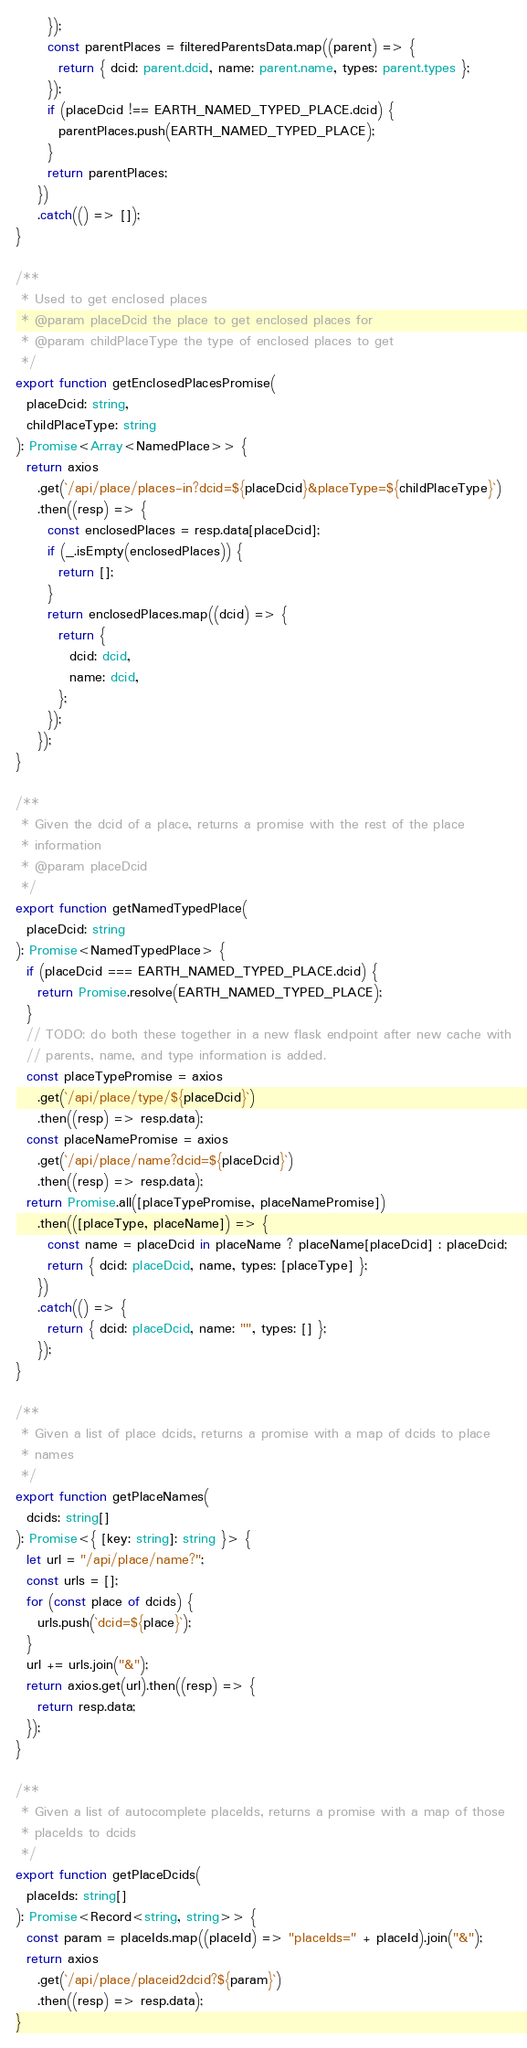<code> <loc_0><loc_0><loc_500><loc_500><_TypeScript_>      });
      const parentPlaces = filteredParentsData.map((parent) => {
        return { dcid: parent.dcid, name: parent.name, types: parent.types };
      });
      if (placeDcid !== EARTH_NAMED_TYPED_PLACE.dcid) {
        parentPlaces.push(EARTH_NAMED_TYPED_PLACE);
      }
      return parentPlaces;
    })
    .catch(() => []);
}

/**
 * Used to get enclosed places
 * @param placeDcid the place to get enclosed places for
 * @param childPlaceType the type of enclosed places to get
 */
export function getEnclosedPlacesPromise(
  placeDcid: string,
  childPlaceType: string
): Promise<Array<NamedPlace>> {
  return axios
    .get(`/api/place/places-in?dcid=${placeDcid}&placeType=${childPlaceType}`)
    .then((resp) => {
      const enclosedPlaces = resp.data[placeDcid];
      if (_.isEmpty(enclosedPlaces)) {
        return [];
      }
      return enclosedPlaces.map((dcid) => {
        return {
          dcid: dcid,
          name: dcid,
        };
      });
    });
}

/**
 * Given the dcid of a place, returns a promise with the rest of the place
 * information
 * @param placeDcid
 */
export function getNamedTypedPlace(
  placeDcid: string
): Promise<NamedTypedPlace> {
  if (placeDcid === EARTH_NAMED_TYPED_PLACE.dcid) {
    return Promise.resolve(EARTH_NAMED_TYPED_PLACE);
  }
  // TODO: do both these together in a new flask endpoint after new cache with
  // parents, name, and type information is added.
  const placeTypePromise = axios
    .get(`/api/place/type/${placeDcid}`)
    .then((resp) => resp.data);
  const placeNamePromise = axios
    .get(`/api/place/name?dcid=${placeDcid}`)
    .then((resp) => resp.data);
  return Promise.all([placeTypePromise, placeNamePromise])
    .then(([placeType, placeName]) => {
      const name = placeDcid in placeName ? placeName[placeDcid] : placeDcid;
      return { dcid: placeDcid, name, types: [placeType] };
    })
    .catch(() => {
      return { dcid: placeDcid, name: "", types: [] };
    });
}

/**
 * Given a list of place dcids, returns a promise with a map of dcids to place
 * names
 */
export function getPlaceNames(
  dcids: string[]
): Promise<{ [key: string]: string }> {
  let url = "/api/place/name?";
  const urls = [];
  for (const place of dcids) {
    urls.push(`dcid=${place}`);
  }
  url += urls.join("&");
  return axios.get(url).then((resp) => {
    return resp.data;
  });
}

/**
 * Given a list of autocomplete placeIds, returns a promise with a map of those
 * placeIds to dcids
 */
export function getPlaceDcids(
  placeIds: string[]
): Promise<Record<string, string>> {
  const param = placeIds.map((placeId) => "placeIds=" + placeId).join("&");
  return axios
    .get(`/api/place/placeid2dcid?${param}`)
    .then((resp) => resp.data);
}
</code> 